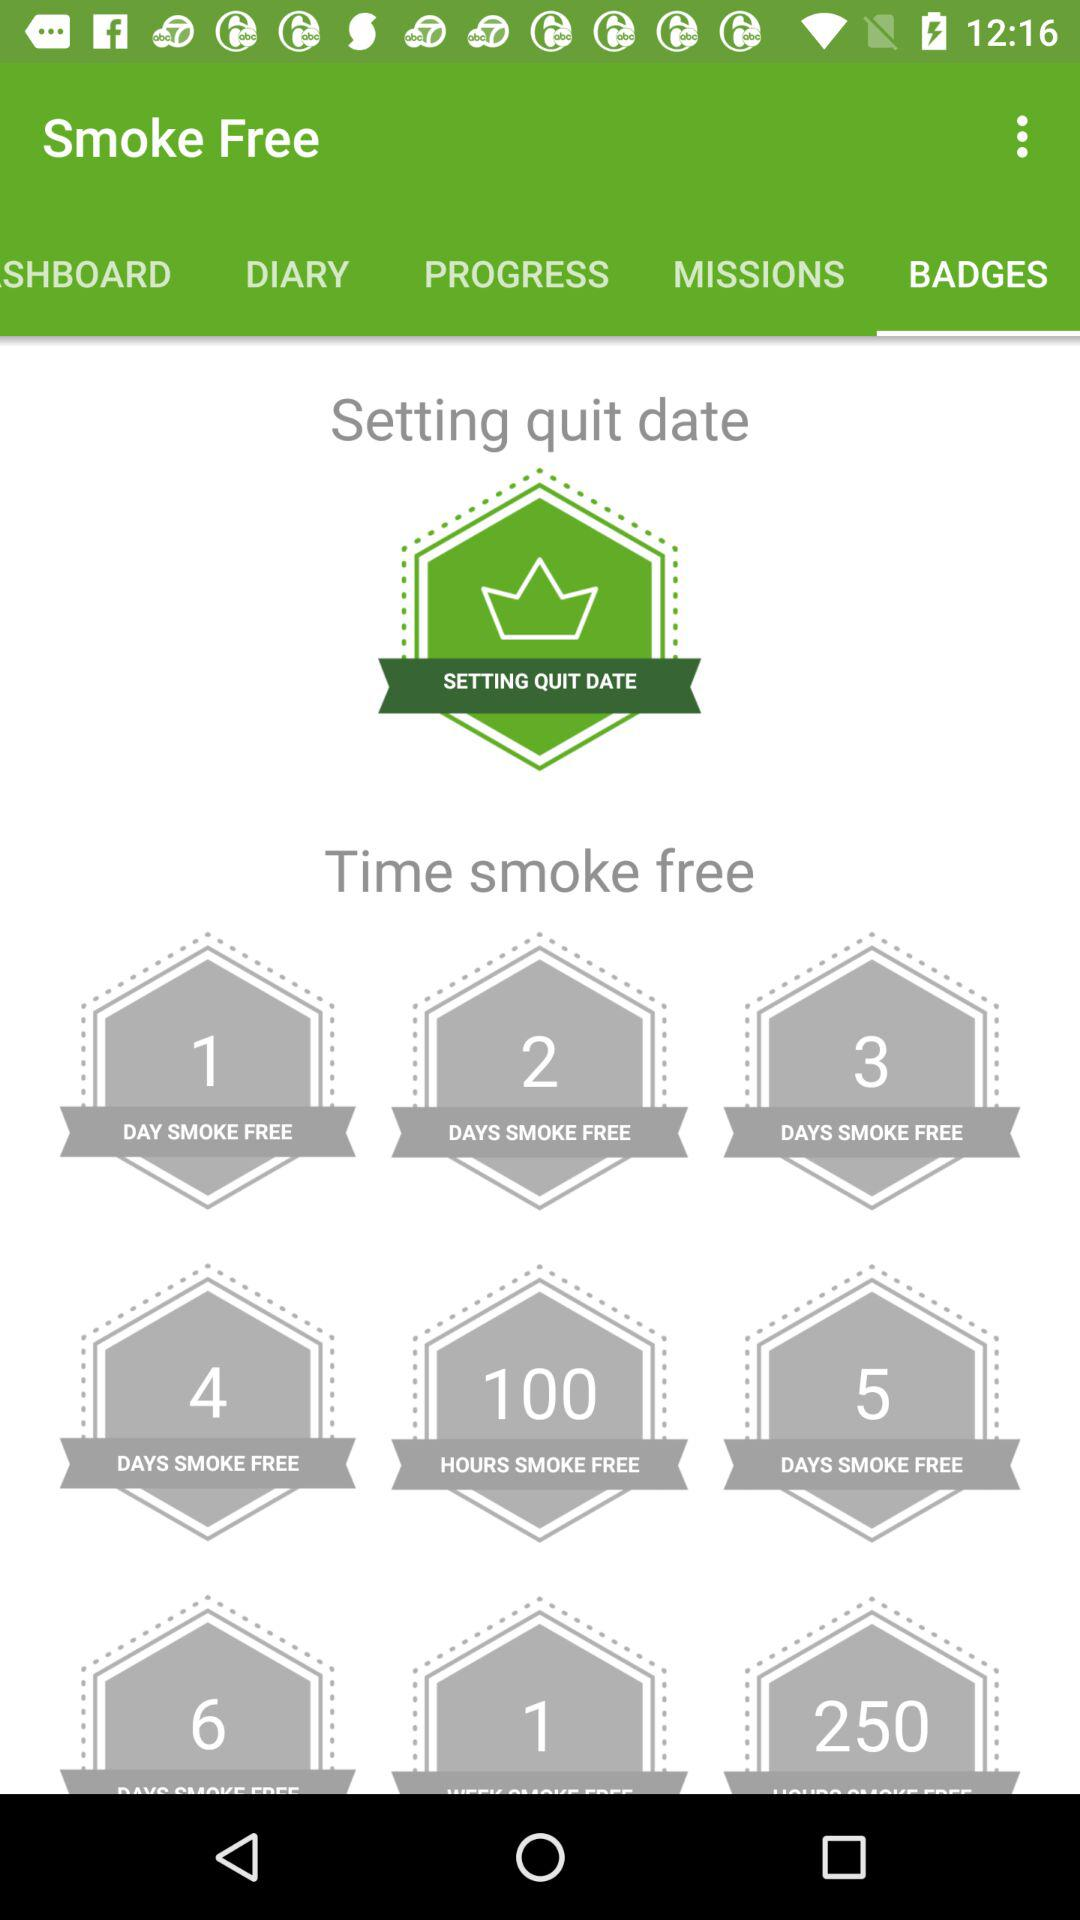What is the application name? The application name is "Smoke Free". 